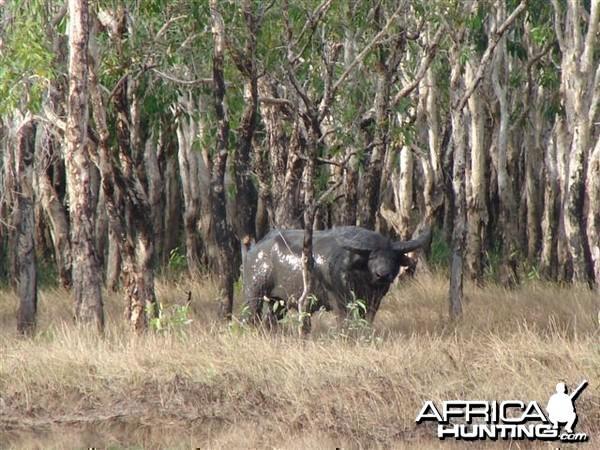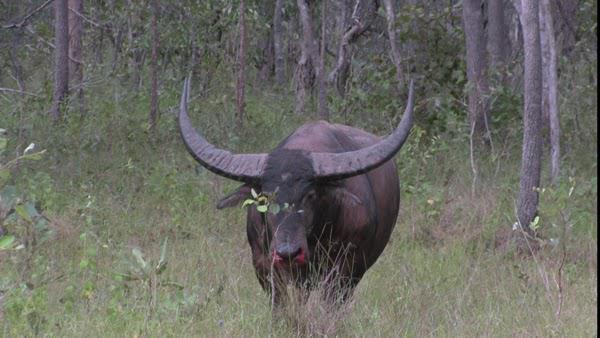The first image is the image on the left, the second image is the image on the right. Evaluate the accuracy of this statement regarding the images: "An image contains at least one person behind a dead water buffalo.". Is it true? Answer yes or no. No. The first image is the image on the left, the second image is the image on the right. Considering the images on both sides, is "There is at least one human in one of the images near a buffalo." valid? Answer yes or no. No. 